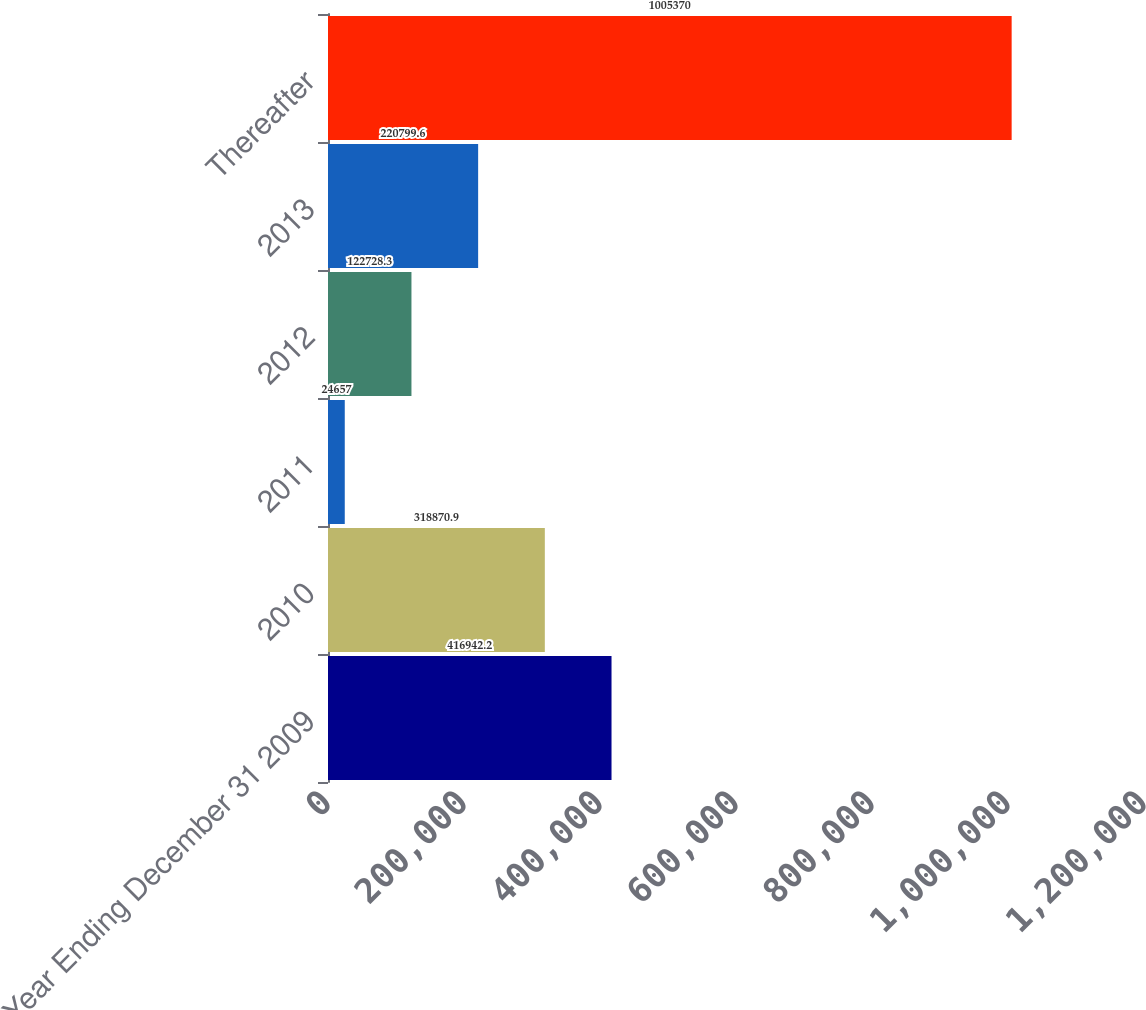<chart> <loc_0><loc_0><loc_500><loc_500><bar_chart><fcel>Year Ending December 31 2009<fcel>2010<fcel>2011<fcel>2012<fcel>2013<fcel>Thereafter<nl><fcel>416942<fcel>318871<fcel>24657<fcel>122728<fcel>220800<fcel>1.00537e+06<nl></chart> 